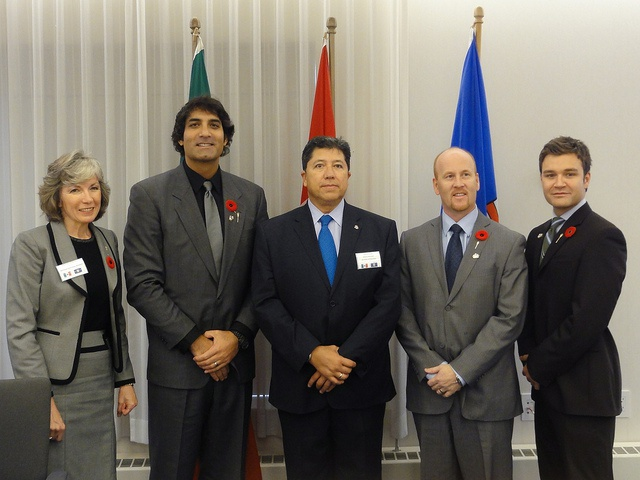Describe the objects in this image and their specific colors. I can see people in lightgray, black, gray, and maroon tones, people in lightgray, black, tan, brown, and blue tones, people in lightgray, black, and gray tones, people in lightgray, gray, and black tones, and people in lightgray, black, tan, darkgray, and gray tones in this image. 